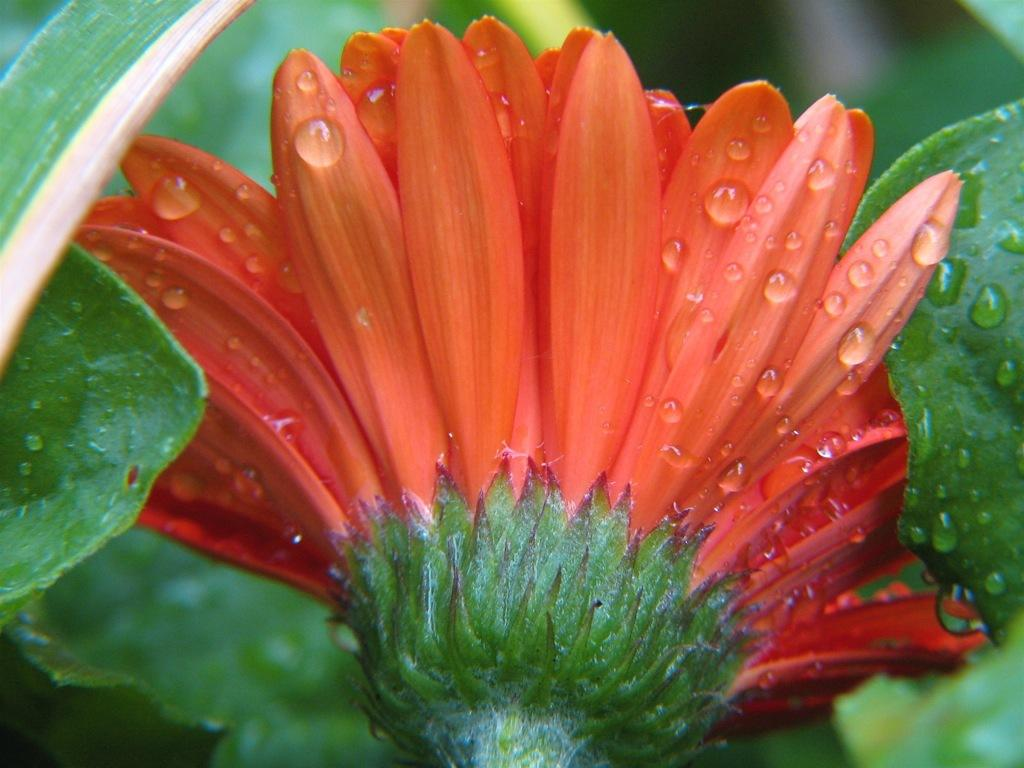What color is the flower in the image? The flower in the image is orange-colored. What color are the leaves surrounding the flower? The leaves on both sides of the flower are green-colored. How many grapes are hanging from the flower in the image? There are no grapes present in the image; it features an orange-colored flower with green leaves. What type of mist can be seen surrounding the flower in the image? There is no mist present in the image; it is a clear image of an orange-colored flower with green leaves. 